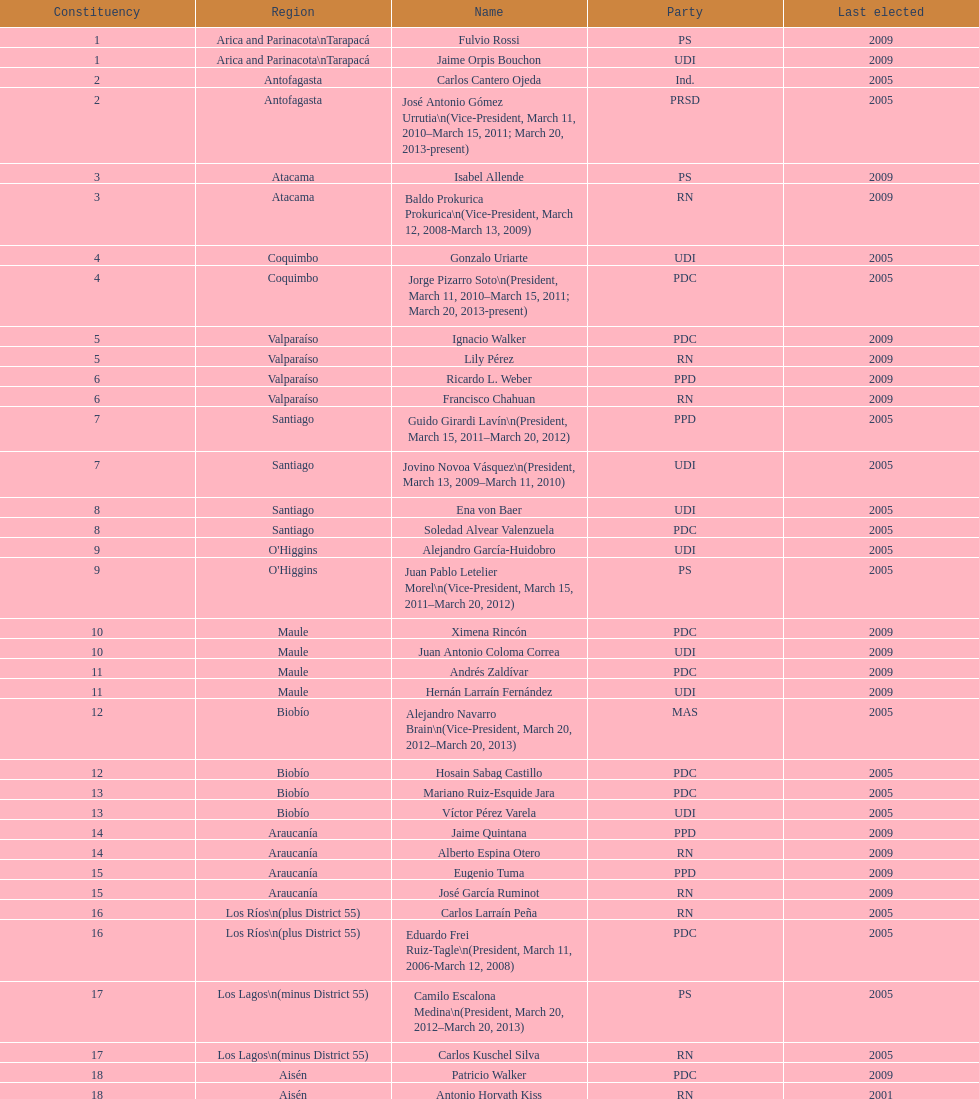What is the final region displayed on the table? Magallanes. 